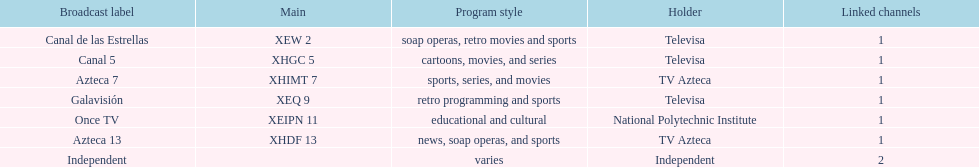How many networks does televisa own? 3. 